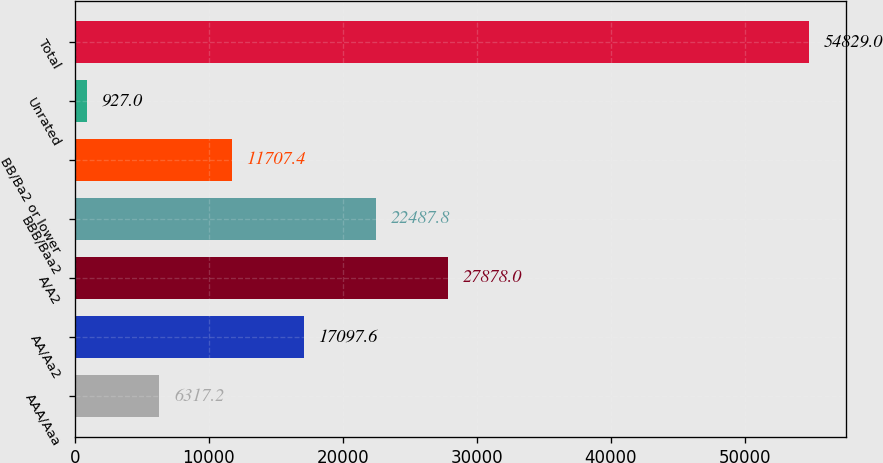<chart> <loc_0><loc_0><loc_500><loc_500><bar_chart><fcel>AAA/Aaa<fcel>AA/Aa2<fcel>A/A2<fcel>BBB/Baa2<fcel>BB/Ba2 or lower<fcel>Unrated<fcel>Total<nl><fcel>6317.2<fcel>17097.6<fcel>27878<fcel>22487.8<fcel>11707.4<fcel>927<fcel>54829<nl></chart> 